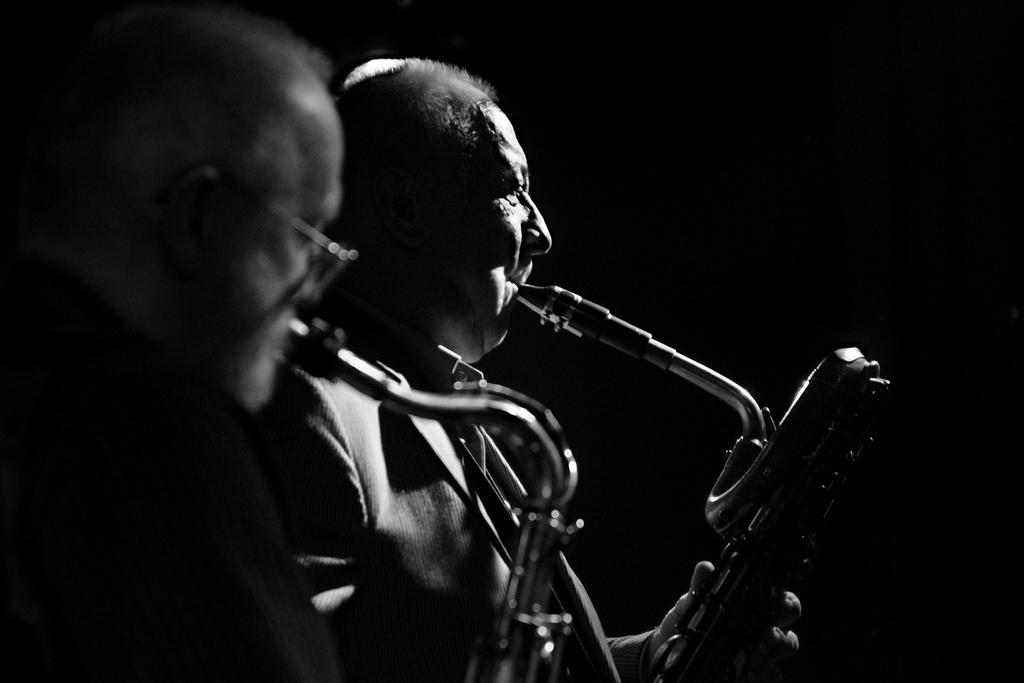What is the color scheme of the image? The image is black and white. Where are the two men located in the image? The two men are standing on the left side of the image. What are the men doing in the image? The men are playing trumpets. What can be seen in the background of the image? The background of the image is dark. How many bulbs are hanging from the wall in the image? There are no bulbs or walls present in the image; it features two men playing trumpets in a dark background. 